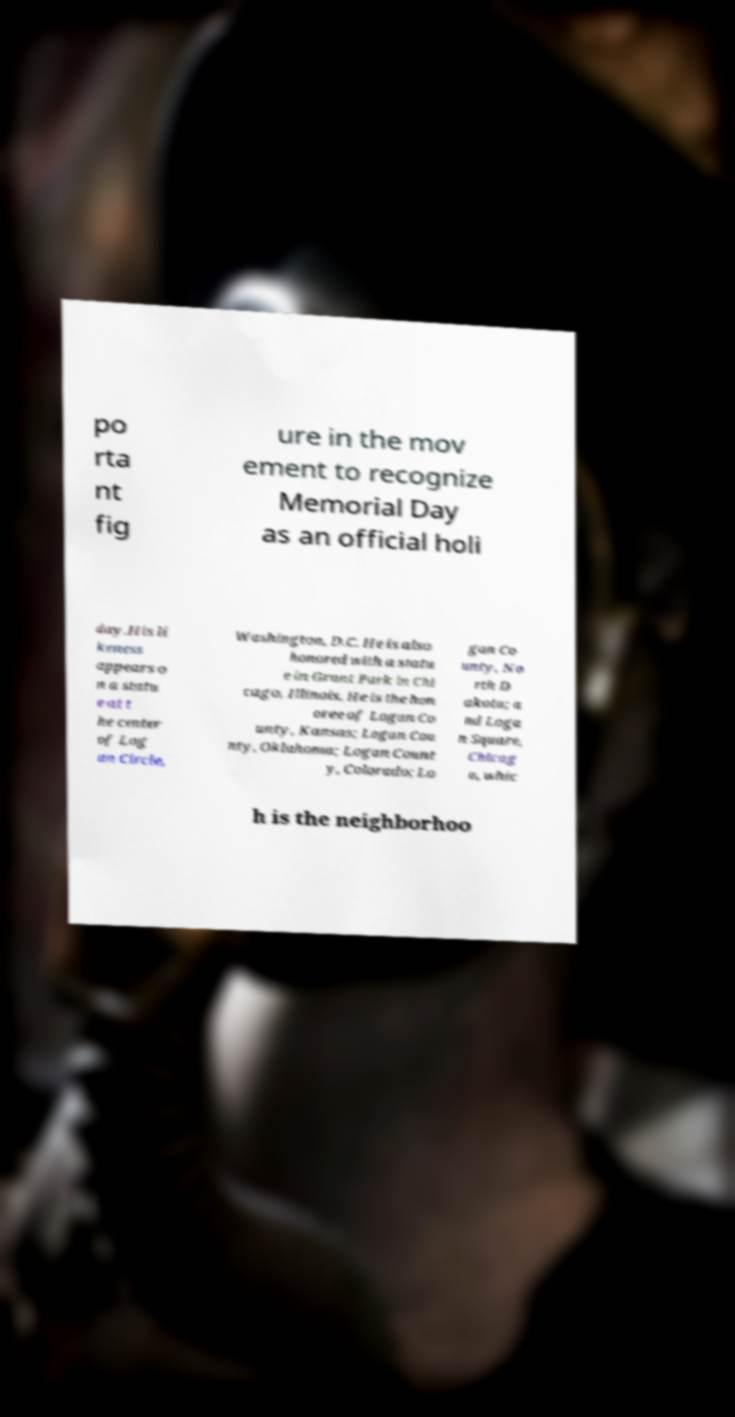There's text embedded in this image that I need extracted. Can you transcribe it verbatim? po rta nt fig ure in the mov ement to recognize Memorial Day as an official holi day.His li keness appears o n a statu e at t he center of Log an Circle, Washington, D.C. He is also honored with a statu e in Grant Park in Chi cago, Illinois. He is the hon oree of Logan Co unty, Kansas; Logan Cou nty, Oklahoma; Logan Count y, Colorado; Lo gan Co unty, No rth D akota; a nd Loga n Square, Chicag o, whic h is the neighborhoo 